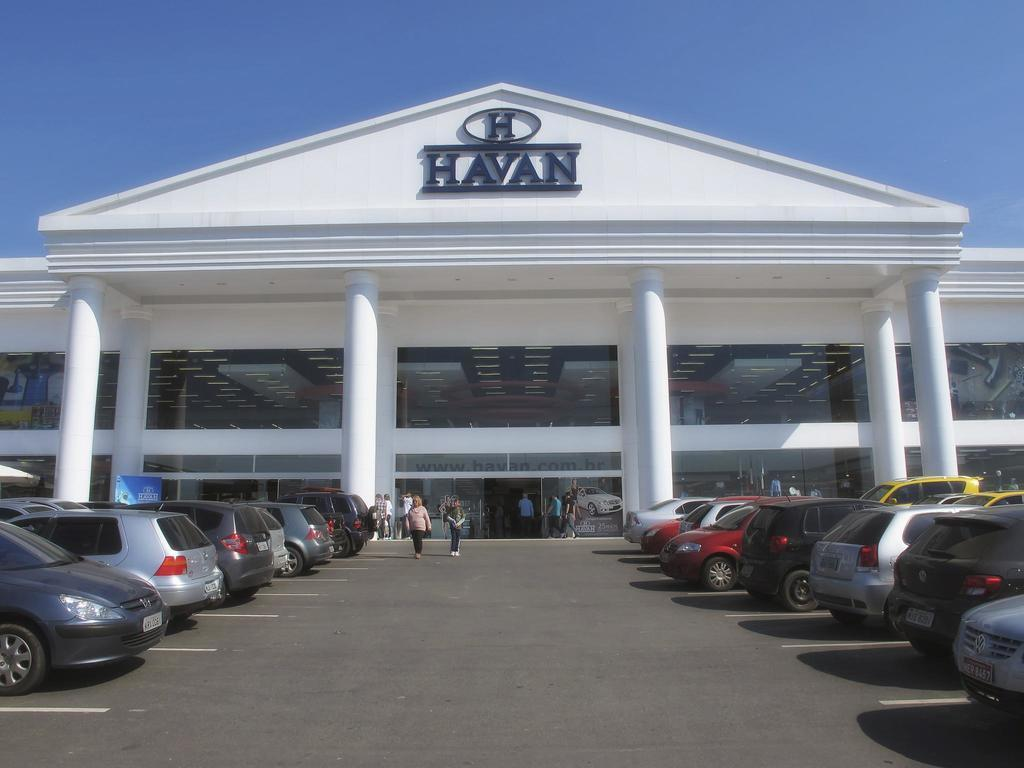What is the main structure in the image? There is a big building in the image. What are the people in the image doing? There are people walking on the road in the image. What else can be seen in the image besides the building and people? There are parked vehicles in the image. How many eggs are visible in the image? There are no eggs present in the image. Where is the bath located in the image? There is no bath present in the image. 